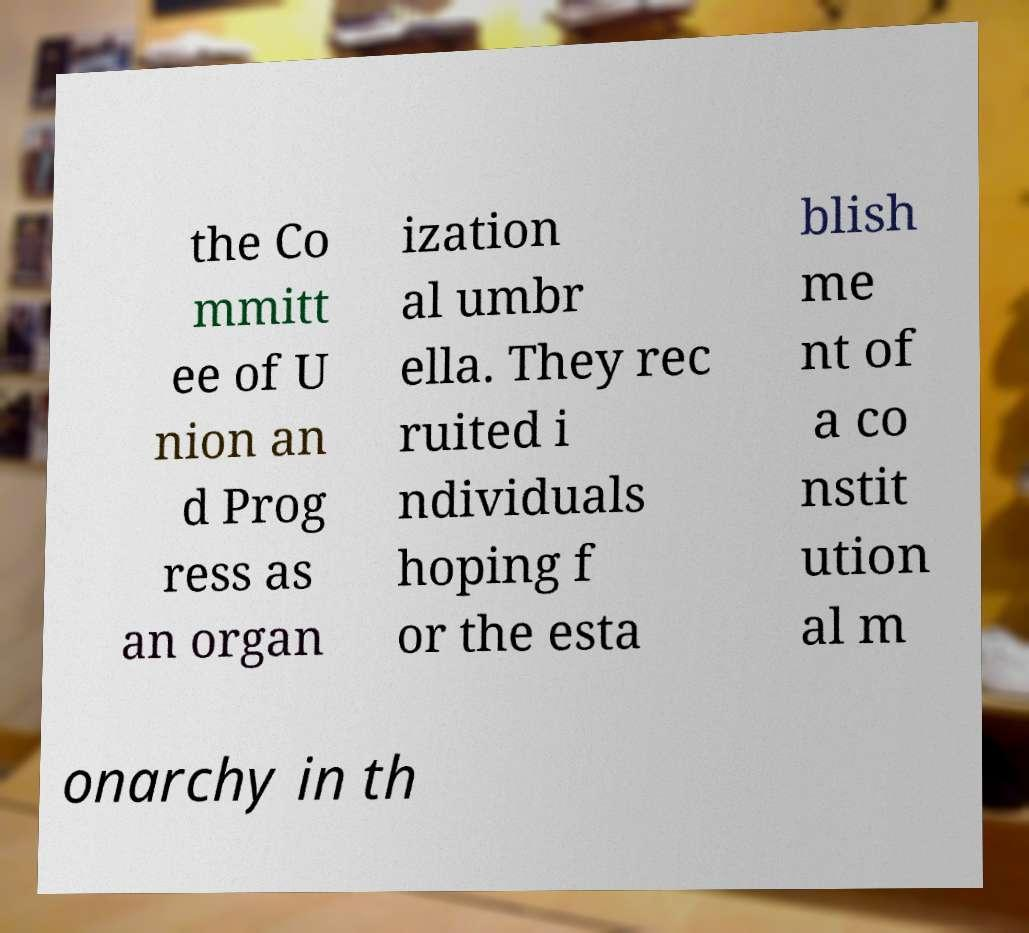What messages or text are displayed in this image? I need them in a readable, typed format. the Co mmitt ee of U nion an d Prog ress as an organ ization al umbr ella. They rec ruited i ndividuals hoping f or the esta blish me nt of a co nstit ution al m onarchy in th 